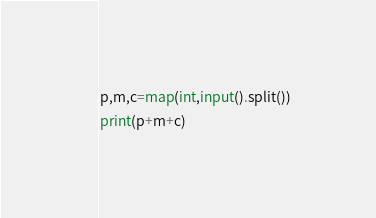Convert code to text. <code><loc_0><loc_0><loc_500><loc_500><_Python_>p,m,c=map(int,input().split())
print(p+m+c)
</code> 